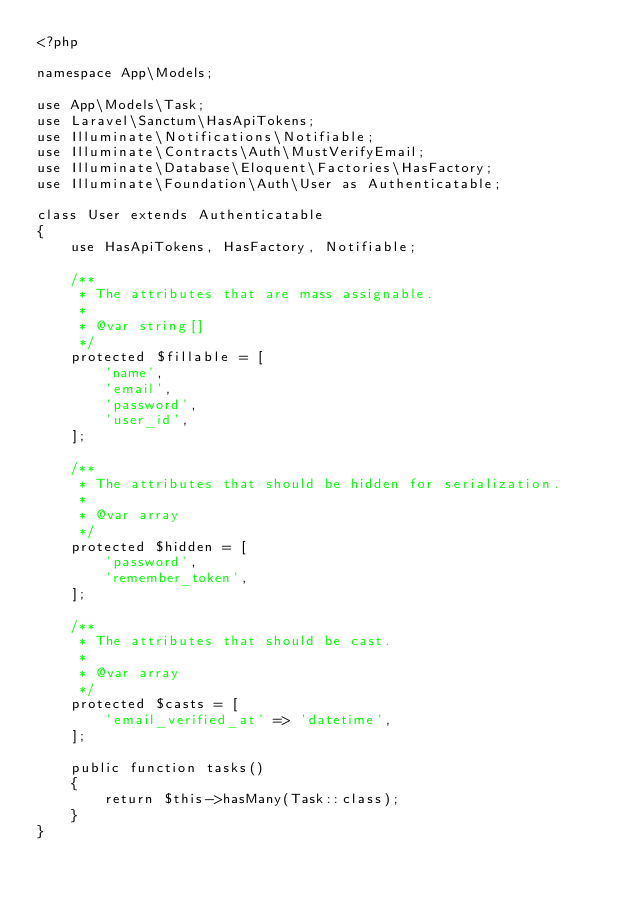Convert code to text. <code><loc_0><loc_0><loc_500><loc_500><_PHP_><?php

namespace App\Models;

use App\Models\Task;
use Laravel\Sanctum\HasApiTokens;
use Illuminate\Notifications\Notifiable;
use Illuminate\Contracts\Auth\MustVerifyEmail;
use Illuminate\Database\Eloquent\Factories\HasFactory;
use Illuminate\Foundation\Auth\User as Authenticatable;

class User extends Authenticatable
{
    use HasApiTokens, HasFactory, Notifiable;

    /**
     * The attributes that are mass assignable.
     *
     * @var string[]
     */
    protected $fillable = [
        'name',
        'email',
        'password',
        'user_id',
    ];

    /**
     * The attributes that should be hidden for serialization.
     *
     * @var array
     */
    protected $hidden = [
        'password',
        'remember_token',
    ];

    /**
     * The attributes that should be cast.
     *
     * @var array
     */
    protected $casts = [
        'email_verified_at' => 'datetime',
    ];

    public function tasks()
    {
        return $this->hasMany(Task::class);
    }
}
</code> 